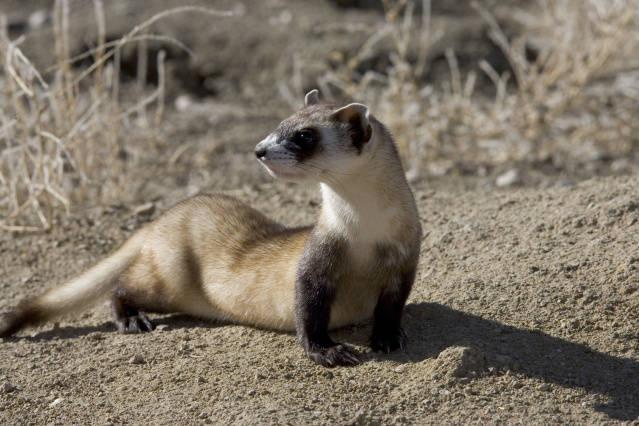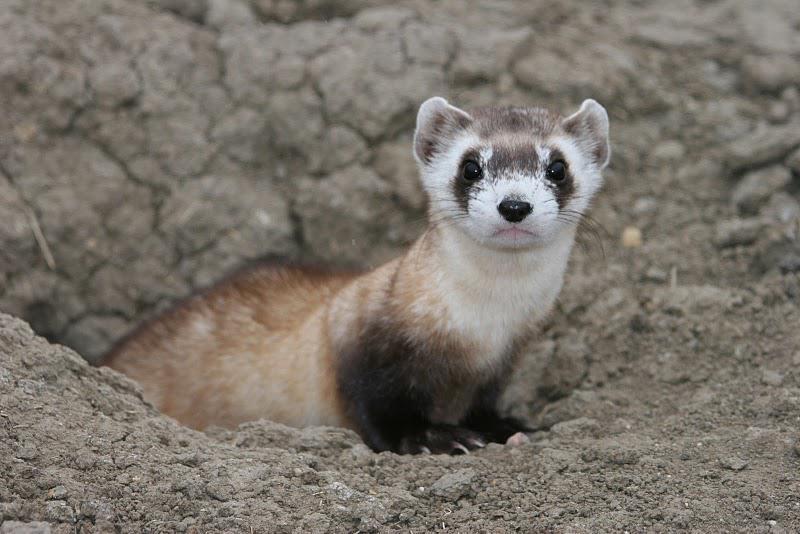The first image is the image on the left, the second image is the image on the right. Assess this claim about the two images: "There are exactly two animals in the image on the left.". Correct or not? Answer yes or no. No. 